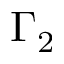<formula> <loc_0><loc_0><loc_500><loc_500>\Gamma _ { 2 }</formula> 